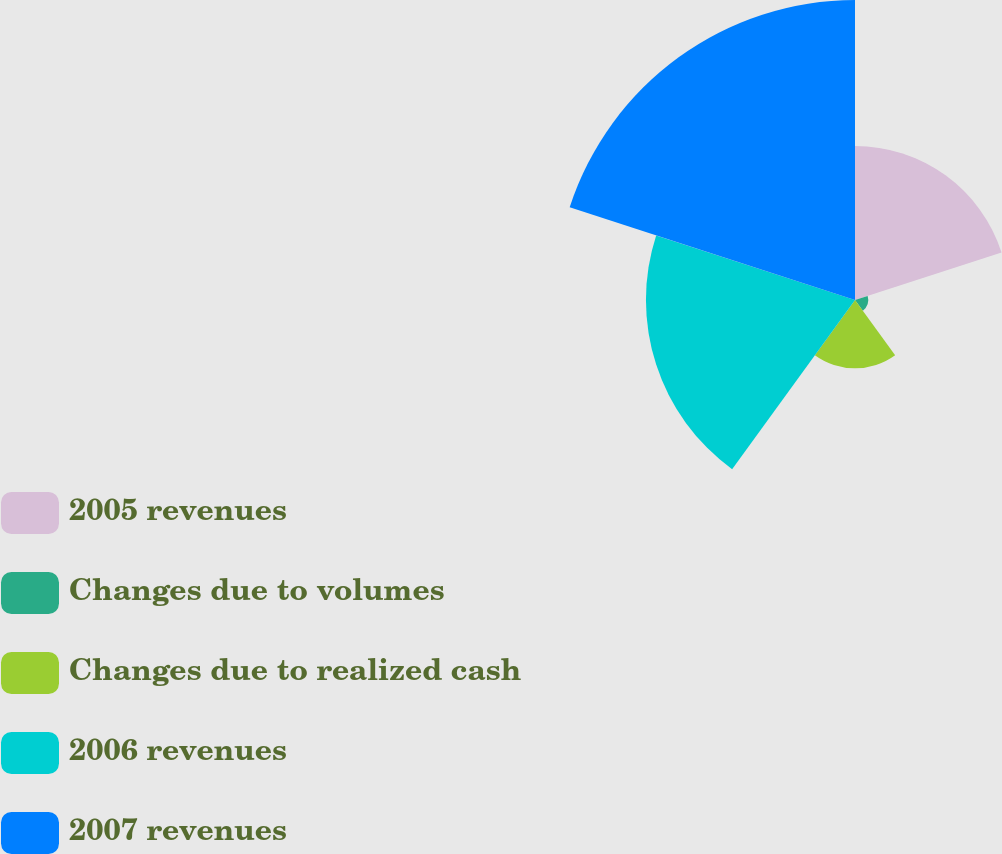Convert chart. <chart><loc_0><loc_0><loc_500><loc_500><pie_chart><fcel>2005 revenues<fcel>Changes due to volumes<fcel>Changes due to realized cash<fcel>2006 revenues<fcel>2007 revenues<nl><fcel>20.69%<fcel>1.79%<fcel>9.17%<fcel>28.07%<fcel>40.28%<nl></chart> 